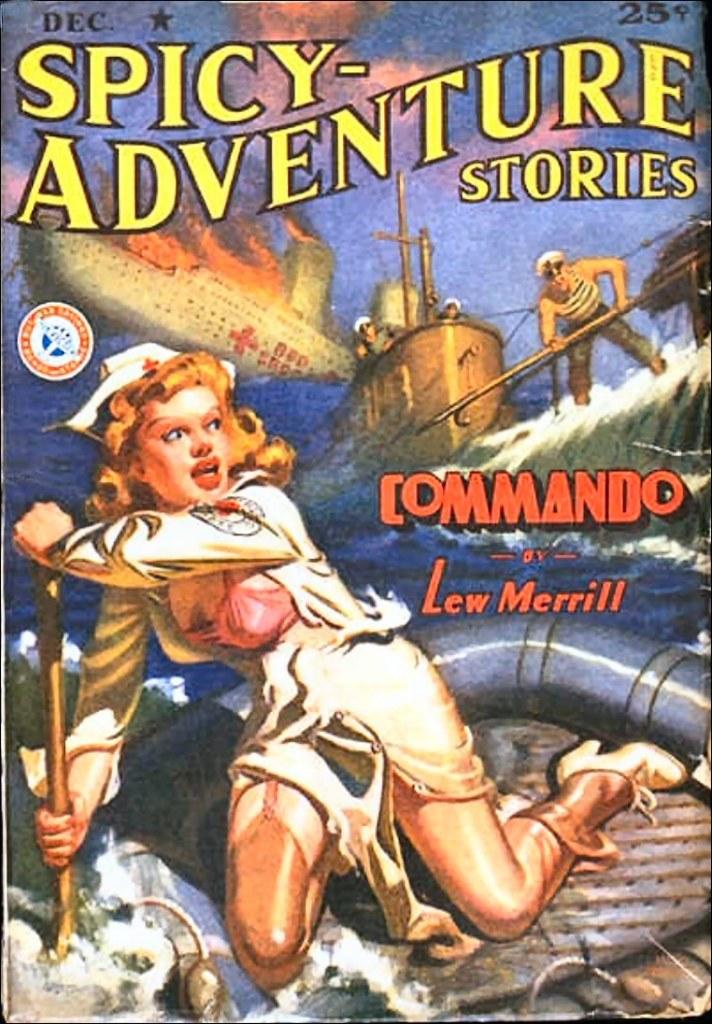What kind of adventure stories are these?
Provide a succinct answer. Spicy. What is the name of the book?
Provide a short and direct response. Spicy-adventure stories. 